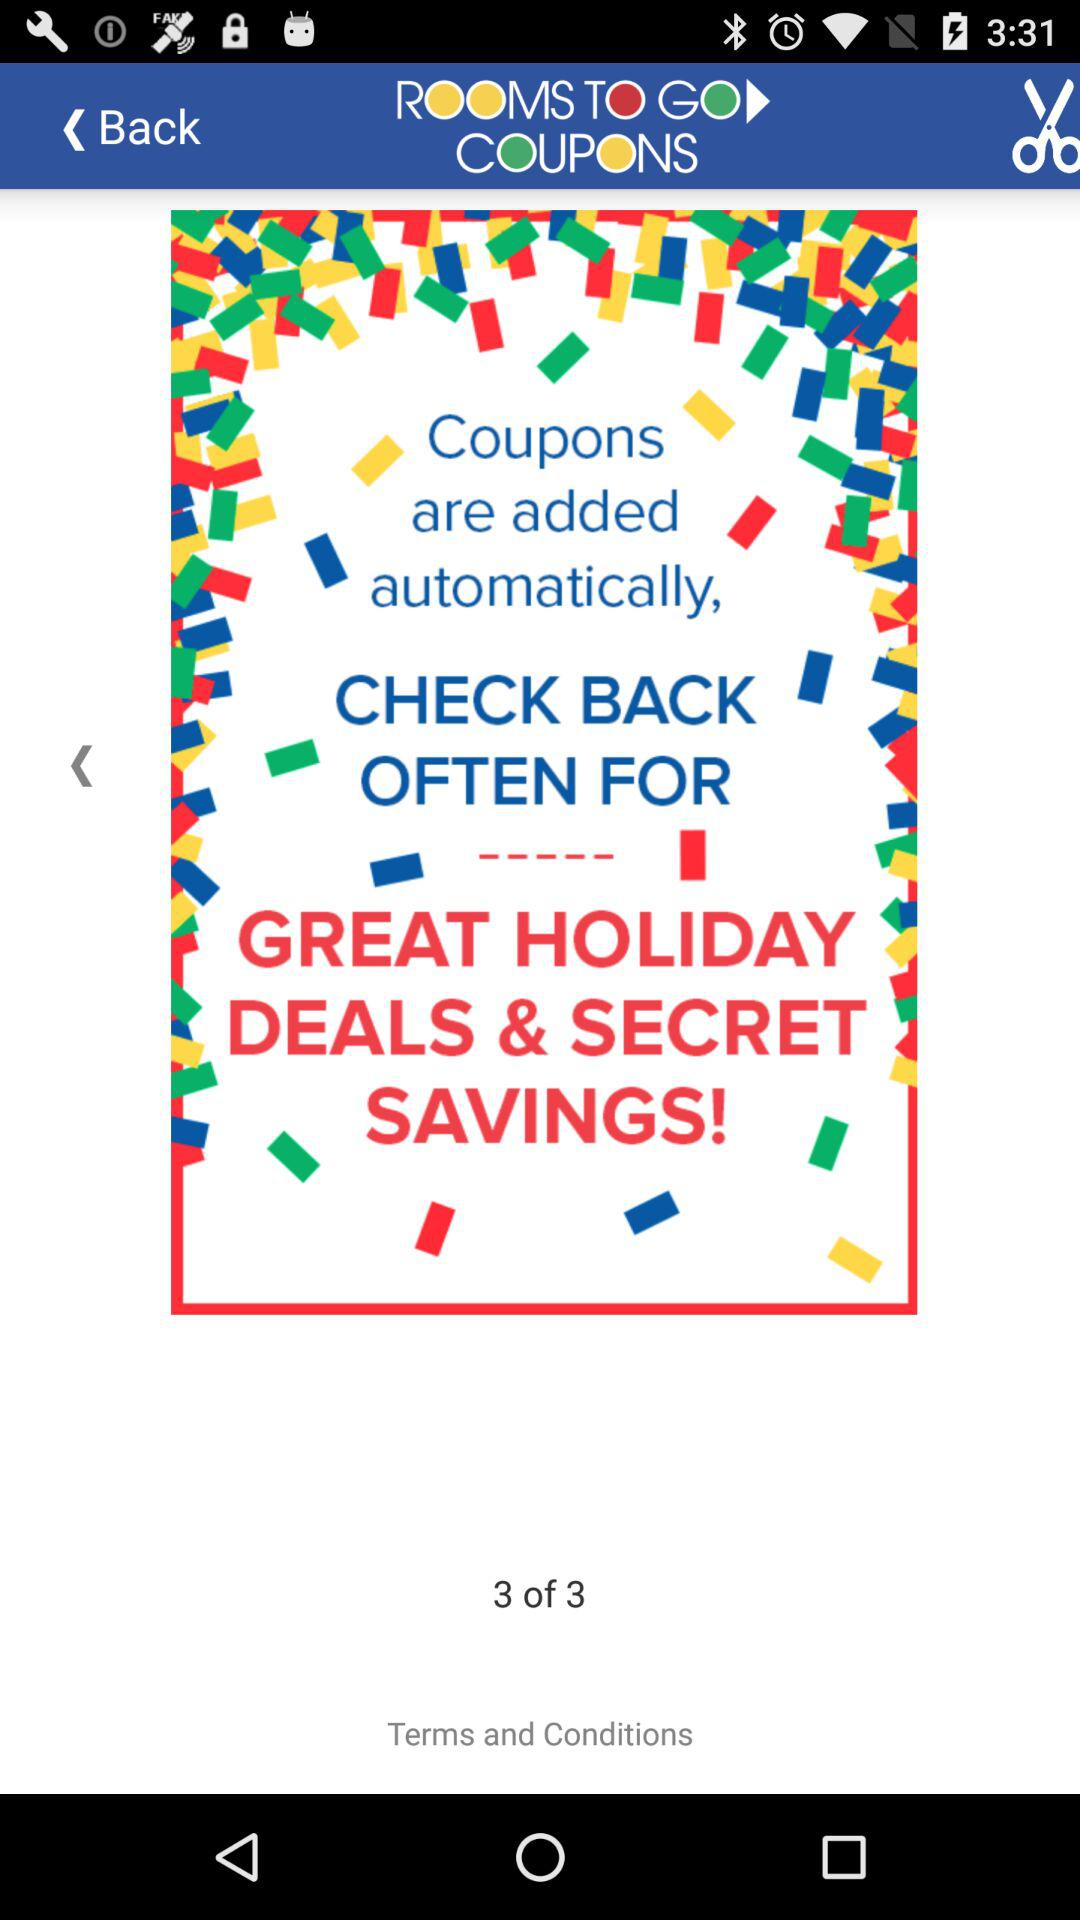How many total pages are there? There are 3 pages. 